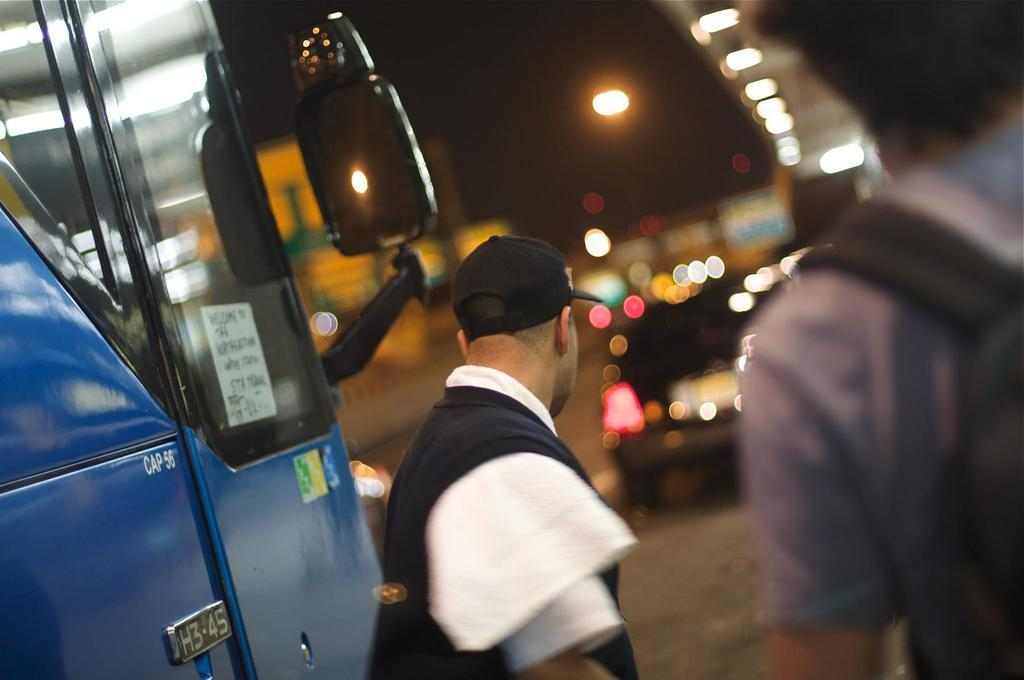What is one characteristic of the person in the image? There is a person with a hat in the image. How many people are present in the image? There are two people in the image. What can be seen on the road in the image? There are vehicles on the road in the image. Can you describe the background of the image? The background of the image is blurred. What type of toothpaste is being used by the person with the hat in the image? There is no toothpaste present in the image, as it is focused on people and vehicles on the road. 